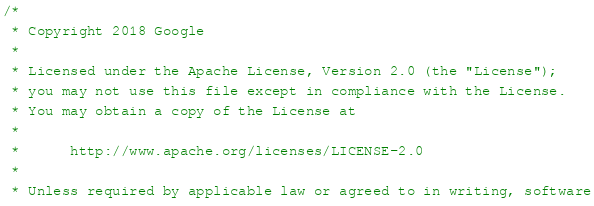Convert code to text. <code><loc_0><loc_0><loc_500><loc_500><_ObjectiveC_>/*
 * Copyright 2018 Google
 *
 * Licensed under the Apache License, Version 2.0 (the "License");
 * you may not use this file except in compliance with the License.
 * You may obtain a copy of the License at
 *
 *      http://www.apache.org/licenses/LICENSE-2.0
 *
 * Unless required by applicable law or agreed to in writing, software</code> 